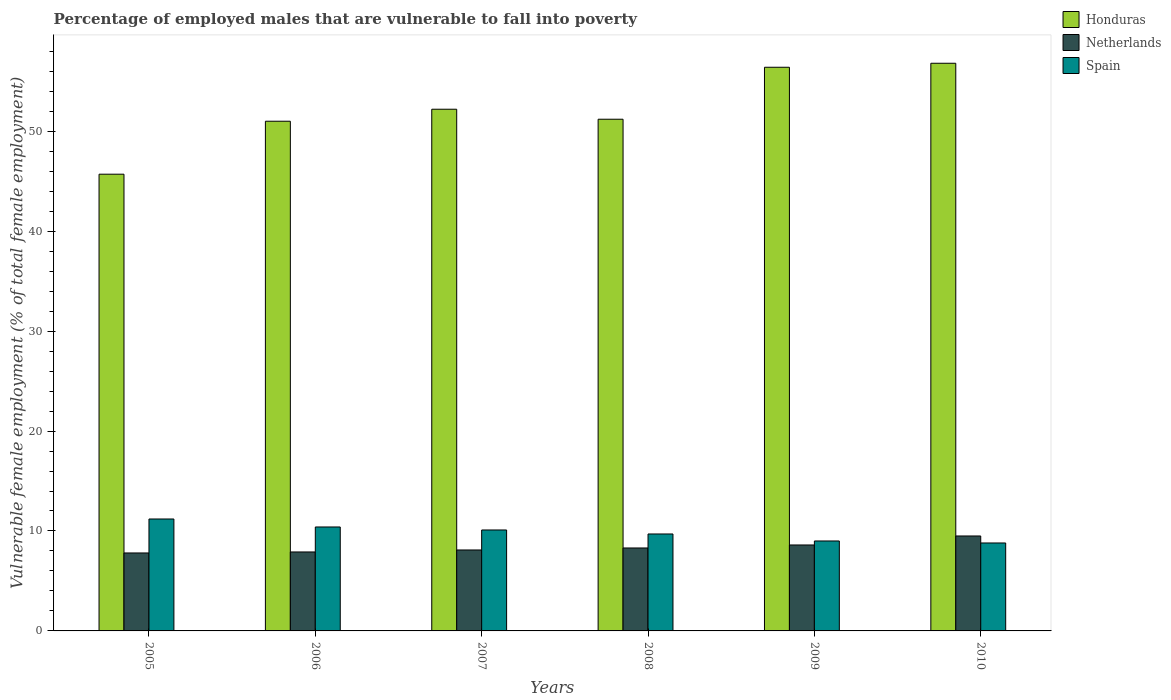Are the number of bars on each tick of the X-axis equal?
Provide a succinct answer. Yes. How many bars are there on the 1st tick from the right?
Offer a very short reply. 3. What is the label of the 4th group of bars from the left?
Your answer should be very brief. 2008. What is the percentage of employed males who are vulnerable to fall into poverty in Spain in 2006?
Make the answer very short. 10.4. Across all years, what is the minimum percentage of employed males who are vulnerable to fall into poverty in Honduras?
Your response must be concise. 45.7. In which year was the percentage of employed males who are vulnerable to fall into poverty in Spain maximum?
Ensure brevity in your answer.  2005. In which year was the percentage of employed males who are vulnerable to fall into poverty in Spain minimum?
Keep it short and to the point. 2010. What is the total percentage of employed males who are vulnerable to fall into poverty in Netherlands in the graph?
Provide a succinct answer. 50.2. What is the difference between the percentage of employed males who are vulnerable to fall into poverty in Honduras in 2005 and that in 2008?
Offer a very short reply. -5.5. What is the difference between the percentage of employed males who are vulnerable to fall into poverty in Honduras in 2007 and the percentage of employed males who are vulnerable to fall into poverty in Spain in 2009?
Your answer should be compact. 43.2. What is the average percentage of employed males who are vulnerable to fall into poverty in Honduras per year?
Keep it short and to the point. 52.22. In the year 2006, what is the difference between the percentage of employed males who are vulnerable to fall into poverty in Spain and percentage of employed males who are vulnerable to fall into poverty in Netherlands?
Provide a short and direct response. 2.5. In how many years, is the percentage of employed males who are vulnerable to fall into poverty in Honduras greater than 44 %?
Your answer should be very brief. 6. What is the ratio of the percentage of employed males who are vulnerable to fall into poverty in Honduras in 2005 to that in 2008?
Your answer should be very brief. 0.89. Is the difference between the percentage of employed males who are vulnerable to fall into poverty in Spain in 2006 and 2009 greater than the difference between the percentage of employed males who are vulnerable to fall into poverty in Netherlands in 2006 and 2009?
Provide a succinct answer. Yes. What is the difference between the highest and the second highest percentage of employed males who are vulnerable to fall into poverty in Spain?
Provide a succinct answer. 0.8. What is the difference between the highest and the lowest percentage of employed males who are vulnerable to fall into poverty in Spain?
Ensure brevity in your answer.  2.4. In how many years, is the percentage of employed males who are vulnerable to fall into poverty in Netherlands greater than the average percentage of employed males who are vulnerable to fall into poverty in Netherlands taken over all years?
Give a very brief answer. 2. Is the sum of the percentage of employed males who are vulnerable to fall into poverty in Honduras in 2005 and 2010 greater than the maximum percentage of employed males who are vulnerable to fall into poverty in Spain across all years?
Your answer should be very brief. Yes. What does the 1st bar from the left in 2008 represents?
Offer a terse response. Honduras. What does the 1st bar from the right in 2005 represents?
Your answer should be very brief. Spain. How many bars are there?
Offer a terse response. 18. What is the difference between two consecutive major ticks on the Y-axis?
Offer a very short reply. 10. Does the graph contain grids?
Your response must be concise. No. What is the title of the graph?
Your response must be concise. Percentage of employed males that are vulnerable to fall into poverty. What is the label or title of the Y-axis?
Offer a very short reply. Vulnerable female employment (% of total female employment). What is the Vulnerable female employment (% of total female employment) of Honduras in 2005?
Offer a very short reply. 45.7. What is the Vulnerable female employment (% of total female employment) of Netherlands in 2005?
Your response must be concise. 7.8. What is the Vulnerable female employment (% of total female employment) in Spain in 2005?
Provide a succinct answer. 11.2. What is the Vulnerable female employment (% of total female employment) of Netherlands in 2006?
Your answer should be very brief. 7.9. What is the Vulnerable female employment (% of total female employment) of Spain in 2006?
Ensure brevity in your answer.  10.4. What is the Vulnerable female employment (% of total female employment) of Honduras in 2007?
Keep it short and to the point. 52.2. What is the Vulnerable female employment (% of total female employment) in Netherlands in 2007?
Provide a succinct answer. 8.1. What is the Vulnerable female employment (% of total female employment) in Spain in 2007?
Your answer should be very brief. 10.1. What is the Vulnerable female employment (% of total female employment) in Honduras in 2008?
Your answer should be compact. 51.2. What is the Vulnerable female employment (% of total female employment) in Netherlands in 2008?
Your answer should be very brief. 8.3. What is the Vulnerable female employment (% of total female employment) in Spain in 2008?
Offer a terse response. 9.7. What is the Vulnerable female employment (% of total female employment) in Honduras in 2009?
Keep it short and to the point. 56.4. What is the Vulnerable female employment (% of total female employment) of Netherlands in 2009?
Provide a short and direct response. 8.6. What is the Vulnerable female employment (% of total female employment) in Honduras in 2010?
Give a very brief answer. 56.8. What is the Vulnerable female employment (% of total female employment) in Spain in 2010?
Your response must be concise. 8.8. Across all years, what is the maximum Vulnerable female employment (% of total female employment) in Honduras?
Keep it short and to the point. 56.8. Across all years, what is the maximum Vulnerable female employment (% of total female employment) in Netherlands?
Your response must be concise. 9.5. Across all years, what is the maximum Vulnerable female employment (% of total female employment) of Spain?
Make the answer very short. 11.2. Across all years, what is the minimum Vulnerable female employment (% of total female employment) of Honduras?
Keep it short and to the point. 45.7. Across all years, what is the minimum Vulnerable female employment (% of total female employment) in Netherlands?
Offer a very short reply. 7.8. Across all years, what is the minimum Vulnerable female employment (% of total female employment) in Spain?
Provide a short and direct response. 8.8. What is the total Vulnerable female employment (% of total female employment) in Honduras in the graph?
Offer a terse response. 313.3. What is the total Vulnerable female employment (% of total female employment) in Netherlands in the graph?
Your response must be concise. 50.2. What is the total Vulnerable female employment (% of total female employment) of Spain in the graph?
Offer a very short reply. 59.2. What is the difference between the Vulnerable female employment (% of total female employment) of Netherlands in 2005 and that in 2006?
Provide a succinct answer. -0.1. What is the difference between the Vulnerable female employment (% of total female employment) in Honduras in 2005 and that in 2007?
Your answer should be very brief. -6.5. What is the difference between the Vulnerable female employment (% of total female employment) of Netherlands in 2005 and that in 2007?
Keep it short and to the point. -0.3. What is the difference between the Vulnerable female employment (% of total female employment) in Spain in 2005 and that in 2007?
Provide a short and direct response. 1.1. What is the difference between the Vulnerable female employment (% of total female employment) in Honduras in 2005 and that in 2008?
Ensure brevity in your answer.  -5.5. What is the difference between the Vulnerable female employment (% of total female employment) in Spain in 2005 and that in 2008?
Offer a terse response. 1.5. What is the difference between the Vulnerable female employment (% of total female employment) in Honduras in 2005 and that in 2009?
Provide a succinct answer. -10.7. What is the difference between the Vulnerable female employment (% of total female employment) in Netherlands in 2005 and that in 2009?
Offer a terse response. -0.8. What is the difference between the Vulnerable female employment (% of total female employment) of Spain in 2005 and that in 2009?
Provide a succinct answer. 2.2. What is the difference between the Vulnerable female employment (% of total female employment) of Spain in 2005 and that in 2010?
Make the answer very short. 2.4. What is the difference between the Vulnerable female employment (% of total female employment) in Netherlands in 2006 and that in 2007?
Make the answer very short. -0.2. What is the difference between the Vulnerable female employment (% of total female employment) of Spain in 2006 and that in 2007?
Your answer should be compact. 0.3. What is the difference between the Vulnerable female employment (% of total female employment) in Honduras in 2006 and that in 2008?
Ensure brevity in your answer.  -0.2. What is the difference between the Vulnerable female employment (% of total female employment) of Netherlands in 2006 and that in 2008?
Provide a succinct answer. -0.4. What is the difference between the Vulnerable female employment (% of total female employment) of Spain in 2006 and that in 2008?
Give a very brief answer. 0.7. What is the difference between the Vulnerable female employment (% of total female employment) of Honduras in 2006 and that in 2009?
Your answer should be very brief. -5.4. What is the difference between the Vulnerable female employment (% of total female employment) in Netherlands in 2006 and that in 2009?
Ensure brevity in your answer.  -0.7. What is the difference between the Vulnerable female employment (% of total female employment) of Spain in 2006 and that in 2009?
Your answer should be compact. 1.4. What is the difference between the Vulnerable female employment (% of total female employment) in Honduras in 2006 and that in 2010?
Offer a terse response. -5.8. What is the difference between the Vulnerable female employment (% of total female employment) of Netherlands in 2006 and that in 2010?
Offer a very short reply. -1.6. What is the difference between the Vulnerable female employment (% of total female employment) in Honduras in 2007 and that in 2008?
Provide a short and direct response. 1. What is the difference between the Vulnerable female employment (% of total female employment) in Netherlands in 2007 and that in 2008?
Your answer should be very brief. -0.2. What is the difference between the Vulnerable female employment (% of total female employment) of Spain in 2007 and that in 2008?
Your response must be concise. 0.4. What is the difference between the Vulnerable female employment (% of total female employment) in Honduras in 2007 and that in 2009?
Provide a short and direct response. -4.2. What is the difference between the Vulnerable female employment (% of total female employment) of Netherlands in 2007 and that in 2009?
Provide a short and direct response. -0.5. What is the difference between the Vulnerable female employment (% of total female employment) in Honduras in 2007 and that in 2010?
Provide a succinct answer. -4.6. What is the difference between the Vulnerable female employment (% of total female employment) in Honduras in 2008 and that in 2009?
Ensure brevity in your answer.  -5.2. What is the difference between the Vulnerable female employment (% of total female employment) in Netherlands in 2008 and that in 2009?
Provide a short and direct response. -0.3. What is the difference between the Vulnerable female employment (% of total female employment) in Netherlands in 2008 and that in 2010?
Your answer should be compact. -1.2. What is the difference between the Vulnerable female employment (% of total female employment) in Netherlands in 2009 and that in 2010?
Your answer should be compact. -0.9. What is the difference between the Vulnerable female employment (% of total female employment) in Honduras in 2005 and the Vulnerable female employment (% of total female employment) in Netherlands in 2006?
Provide a short and direct response. 37.8. What is the difference between the Vulnerable female employment (% of total female employment) of Honduras in 2005 and the Vulnerable female employment (% of total female employment) of Spain in 2006?
Offer a very short reply. 35.3. What is the difference between the Vulnerable female employment (% of total female employment) of Netherlands in 2005 and the Vulnerable female employment (% of total female employment) of Spain in 2006?
Your answer should be compact. -2.6. What is the difference between the Vulnerable female employment (% of total female employment) in Honduras in 2005 and the Vulnerable female employment (% of total female employment) in Netherlands in 2007?
Keep it short and to the point. 37.6. What is the difference between the Vulnerable female employment (% of total female employment) of Honduras in 2005 and the Vulnerable female employment (% of total female employment) of Spain in 2007?
Keep it short and to the point. 35.6. What is the difference between the Vulnerable female employment (% of total female employment) in Netherlands in 2005 and the Vulnerable female employment (% of total female employment) in Spain in 2007?
Offer a very short reply. -2.3. What is the difference between the Vulnerable female employment (% of total female employment) in Honduras in 2005 and the Vulnerable female employment (% of total female employment) in Netherlands in 2008?
Make the answer very short. 37.4. What is the difference between the Vulnerable female employment (% of total female employment) in Honduras in 2005 and the Vulnerable female employment (% of total female employment) in Spain in 2008?
Your answer should be very brief. 36. What is the difference between the Vulnerable female employment (% of total female employment) in Netherlands in 2005 and the Vulnerable female employment (% of total female employment) in Spain in 2008?
Offer a very short reply. -1.9. What is the difference between the Vulnerable female employment (% of total female employment) in Honduras in 2005 and the Vulnerable female employment (% of total female employment) in Netherlands in 2009?
Your answer should be very brief. 37.1. What is the difference between the Vulnerable female employment (% of total female employment) in Honduras in 2005 and the Vulnerable female employment (% of total female employment) in Spain in 2009?
Your response must be concise. 36.7. What is the difference between the Vulnerable female employment (% of total female employment) in Honduras in 2005 and the Vulnerable female employment (% of total female employment) in Netherlands in 2010?
Ensure brevity in your answer.  36.2. What is the difference between the Vulnerable female employment (% of total female employment) of Honduras in 2005 and the Vulnerable female employment (% of total female employment) of Spain in 2010?
Your answer should be very brief. 36.9. What is the difference between the Vulnerable female employment (% of total female employment) in Netherlands in 2005 and the Vulnerable female employment (% of total female employment) in Spain in 2010?
Your answer should be very brief. -1. What is the difference between the Vulnerable female employment (% of total female employment) of Honduras in 2006 and the Vulnerable female employment (% of total female employment) of Netherlands in 2007?
Your response must be concise. 42.9. What is the difference between the Vulnerable female employment (% of total female employment) in Honduras in 2006 and the Vulnerable female employment (% of total female employment) in Spain in 2007?
Make the answer very short. 40.9. What is the difference between the Vulnerable female employment (% of total female employment) of Honduras in 2006 and the Vulnerable female employment (% of total female employment) of Netherlands in 2008?
Provide a short and direct response. 42.7. What is the difference between the Vulnerable female employment (% of total female employment) of Honduras in 2006 and the Vulnerable female employment (% of total female employment) of Spain in 2008?
Your answer should be very brief. 41.3. What is the difference between the Vulnerable female employment (% of total female employment) of Netherlands in 2006 and the Vulnerable female employment (% of total female employment) of Spain in 2008?
Keep it short and to the point. -1.8. What is the difference between the Vulnerable female employment (% of total female employment) in Honduras in 2006 and the Vulnerable female employment (% of total female employment) in Netherlands in 2009?
Your response must be concise. 42.4. What is the difference between the Vulnerable female employment (% of total female employment) of Honduras in 2006 and the Vulnerable female employment (% of total female employment) of Netherlands in 2010?
Keep it short and to the point. 41.5. What is the difference between the Vulnerable female employment (% of total female employment) in Honduras in 2006 and the Vulnerable female employment (% of total female employment) in Spain in 2010?
Provide a short and direct response. 42.2. What is the difference between the Vulnerable female employment (% of total female employment) in Netherlands in 2006 and the Vulnerable female employment (% of total female employment) in Spain in 2010?
Make the answer very short. -0.9. What is the difference between the Vulnerable female employment (% of total female employment) of Honduras in 2007 and the Vulnerable female employment (% of total female employment) of Netherlands in 2008?
Your answer should be very brief. 43.9. What is the difference between the Vulnerable female employment (% of total female employment) of Honduras in 2007 and the Vulnerable female employment (% of total female employment) of Spain in 2008?
Ensure brevity in your answer.  42.5. What is the difference between the Vulnerable female employment (% of total female employment) in Netherlands in 2007 and the Vulnerable female employment (% of total female employment) in Spain in 2008?
Offer a terse response. -1.6. What is the difference between the Vulnerable female employment (% of total female employment) in Honduras in 2007 and the Vulnerable female employment (% of total female employment) in Netherlands in 2009?
Keep it short and to the point. 43.6. What is the difference between the Vulnerable female employment (% of total female employment) in Honduras in 2007 and the Vulnerable female employment (% of total female employment) in Spain in 2009?
Your answer should be compact. 43.2. What is the difference between the Vulnerable female employment (% of total female employment) in Netherlands in 2007 and the Vulnerable female employment (% of total female employment) in Spain in 2009?
Provide a succinct answer. -0.9. What is the difference between the Vulnerable female employment (% of total female employment) in Honduras in 2007 and the Vulnerable female employment (% of total female employment) in Netherlands in 2010?
Make the answer very short. 42.7. What is the difference between the Vulnerable female employment (% of total female employment) of Honduras in 2007 and the Vulnerable female employment (% of total female employment) of Spain in 2010?
Your response must be concise. 43.4. What is the difference between the Vulnerable female employment (% of total female employment) in Netherlands in 2007 and the Vulnerable female employment (% of total female employment) in Spain in 2010?
Your answer should be compact. -0.7. What is the difference between the Vulnerable female employment (% of total female employment) in Honduras in 2008 and the Vulnerable female employment (% of total female employment) in Netherlands in 2009?
Make the answer very short. 42.6. What is the difference between the Vulnerable female employment (% of total female employment) in Honduras in 2008 and the Vulnerable female employment (% of total female employment) in Spain in 2009?
Your answer should be compact. 42.2. What is the difference between the Vulnerable female employment (% of total female employment) in Honduras in 2008 and the Vulnerable female employment (% of total female employment) in Netherlands in 2010?
Your answer should be very brief. 41.7. What is the difference between the Vulnerable female employment (% of total female employment) in Honduras in 2008 and the Vulnerable female employment (% of total female employment) in Spain in 2010?
Your answer should be very brief. 42.4. What is the difference between the Vulnerable female employment (% of total female employment) of Netherlands in 2008 and the Vulnerable female employment (% of total female employment) of Spain in 2010?
Provide a succinct answer. -0.5. What is the difference between the Vulnerable female employment (% of total female employment) in Honduras in 2009 and the Vulnerable female employment (% of total female employment) in Netherlands in 2010?
Provide a succinct answer. 46.9. What is the difference between the Vulnerable female employment (% of total female employment) in Honduras in 2009 and the Vulnerable female employment (% of total female employment) in Spain in 2010?
Ensure brevity in your answer.  47.6. What is the difference between the Vulnerable female employment (% of total female employment) in Netherlands in 2009 and the Vulnerable female employment (% of total female employment) in Spain in 2010?
Offer a terse response. -0.2. What is the average Vulnerable female employment (% of total female employment) in Honduras per year?
Provide a succinct answer. 52.22. What is the average Vulnerable female employment (% of total female employment) of Netherlands per year?
Your answer should be very brief. 8.37. What is the average Vulnerable female employment (% of total female employment) in Spain per year?
Offer a very short reply. 9.87. In the year 2005, what is the difference between the Vulnerable female employment (% of total female employment) in Honduras and Vulnerable female employment (% of total female employment) in Netherlands?
Give a very brief answer. 37.9. In the year 2005, what is the difference between the Vulnerable female employment (% of total female employment) of Honduras and Vulnerable female employment (% of total female employment) of Spain?
Your answer should be very brief. 34.5. In the year 2005, what is the difference between the Vulnerable female employment (% of total female employment) of Netherlands and Vulnerable female employment (% of total female employment) of Spain?
Offer a very short reply. -3.4. In the year 2006, what is the difference between the Vulnerable female employment (% of total female employment) in Honduras and Vulnerable female employment (% of total female employment) in Netherlands?
Ensure brevity in your answer.  43.1. In the year 2006, what is the difference between the Vulnerable female employment (% of total female employment) in Honduras and Vulnerable female employment (% of total female employment) in Spain?
Your answer should be very brief. 40.6. In the year 2007, what is the difference between the Vulnerable female employment (% of total female employment) of Honduras and Vulnerable female employment (% of total female employment) of Netherlands?
Provide a succinct answer. 44.1. In the year 2007, what is the difference between the Vulnerable female employment (% of total female employment) in Honduras and Vulnerable female employment (% of total female employment) in Spain?
Offer a very short reply. 42.1. In the year 2008, what is the difference between the Vulnerable female employment (% of total female employment) in Honduras and Vulnerable female employment (% of total female employment) in Netherlands?
Offer a very short reply. 42.9. In the year 2008, what is the difference between the Vulnerable female employment (% of total female employment) of Honduras and Vulnerable female employment (% of total female employment) of Spain?
Provide a succinct answer. 41.5. In the year 2008, what is the difference between the Vulnerable female employment (% of total female employment) of Netherlands and Vulnerable female employment (% of total female employment) of Spain?
Your answer should be very brief. -1.4. In the year 2009, what is the difference between the Vulnerable female employment (% of total female employment) of Honduras and Vulnerable female employment (% of total female employment) of Netherlands?
Provide a succinct answer. 47.8. In the year 2009, what is the difference between the Vulnerable female employment (% of total female employment) of Honduras and Vulnerable female employment (% of total female employment) of Spain?
Make the answer very short. 47.4. In the year 2010, what is the difference between the Vulnerable female employment (% of total female employment) of Honduras and Vulnerable female employment (% of total female employment) of Netherlands?
Your answer should be very brief. 47.3. In the year 2010, what is the difference between the Vulnerable female employment (% of total female employment) in Honduras and Vulnerable female employment (% of total female employment) in Spain?
Your response must be concise. 48. In the year 2010, what is the difference between the Vulnerable female employment (% of total female employment) in Netherlands and Vulnerable female employment (% of total female employment) in Spain?
Your answer should be compact. 0.7. What is the ratio of the Vulnerable female employment (% of total female employment) in Honduras in 2005 to that in 2006?
Your answer should be very brief. 0.9. What is the ratio of the Vulnerable female employment (% of total female employment) of Netherlands in 2005 to that in 2006?
Offer a terse response. 0.99. What is the ratio of the Vulnerable female employment (% of total female employment) in Honduras in 2005 to that in 2007?
Offer a very short reply. 0.88. What is the ratio of the Vulnerable female employment (% of total female employment) of Spain in 2005 to that in 2007?
Ensure brevity in your answer.  1.11. What is the ratio of the Vulnerable female employment (% of total female employment) of Honduras in 2005 to that in 2008?
Make the answer very short. 0.89. What is the ratio of the Vulnerable female employment (% of total female employment) of Netherlands in 2005 to that in 2008?
Provide a short and direct response. 0.94. What is the ratio of the Vulnerable female employment (% of total female employment) of Spain in 2005 to that in 2008?
Give a very brief answer. 1.15. What is the ratio of the Vulnerable female employment (% of total female employment) of Honduras in 2005 to that in 2009?
Offer a terse response. 0.81. What is the ratio of the Vulnerable female employment (% of total female employment) in Netherlands in 2005 to that in 2009?
Give a very brief answer. 0.91. What is the ratio of the Vulnerable female employment (% of total female employment) in Spain in 2005 to that in 2009?
Give a very brief answer. 1.24. What is the ratio of the Vulnerable female employment (% of total female employment) in Honduras in 2005 to that in 2010?
Make the answer very short. 0.8. What is the ratio of the Vulnerable female employment (% of total female employment) of Netherlands in 2005 to that in 2010?
Ensure brevity in your answer.  0.82. What is the ratio of the Vulnerable female employment (% of total female employment) in Spain in 2005 to that in 2010?
Keep it short and to the point. 1.27. What is the ratio of the Vulnerable female employment (% of total female employment) of Netherlands in 2006 to that in 2007?
Your response must be concise. 0.98. What is the ratio of the Vulnerable female employment (% of total female employment) of Spain in 2006 to that in 2007?
Your answer should be compact. 1.03. What is the ratio of the Vulnerable female employment (% of total female employment) in Honduras in 2006 to that in 2008?
Offer a very short reply. 1. What is the ratio of the Vulnerable female employment (% of total female employment) of Netherlands in 2006 to that in 2008?
Provide a short and direct response. 0.95. What is the ratio of the Vulnerable female employment (% of total female employment) of Spain in 2006 to that in 2008?
Provide a short and direct response. 1.07. What is the ratio of the Vulnerable female employment (% of total female employment) in Honduras in 2006 to that in 2009?
Make the answer very short. 0.9. What is the ratio of the Vulnerable female employment (% of total female employment) in Netherlands in 2006 to that in 2009?
Give a very brief answer. 0.92. What is the ratio of the Vulnerable female employment (% of total female employment) in Spain in 2006 to that in 2009?
Keep it short and to the point. 1.16. What is the ratio of the Vulnerable female employment (% of total female employment) in Honduras in 2006 to that in 2010?
Provide a succinct answer. 0.9. What is the ratio of the Vulnerable female employment (% of total female employment) of Netherlands in 2006 to that in 2010?
Your response must be concise. 0.83. What is the ratio of the Vulnerable female employment (% of total female employment) in Spain in 2006 to that in 2010?
Give a very brief answer. 1.18. What is the ratio of the Vulnerable female employment (% of total female employment) of Honduras in 2007 to that in 2008?
Your answer should be very brief. 1.02. What is the ratio of the Vulnerable female employment (% of total female employment) in Netherlands in 2007 to that in 2008?
Your response must be concise. 0.98. What is the ratio of the Vulnerable female employment (% of total female employment) of Spain in 2007 to that in 2008?
Offer a very short reply. 1.04. What is the ratio of the Vulnerable female employment (% of total female employment) in Honduras in 2007 to that in 2009?
Provide a succinct answer. 0.93. What is the ratio of the Vulnerable female employment (% of total female employment) in Netherlands in 2007 to that in 2009?
Your response must be concise. 0.94. What is the ratio of the Vulnerable female employment (% of total female employment) in Spain in 2007 to that in 2009?
Ensure brevity in your answer.  1.12. What is the ratio of the Vulnerable female employment (% of total female employment) in Honduras in 2007 to that in 2010?
Provide a succinct answer. 0.92. What is the ratio of the Vulnerable female employment (% of total female employment) in Netherlands in 2007 to that in 2010?
Your answer should be very brief. 0.85. What is the ratio of the Vulnerable female employment (% of total female employment) in Spain in 2007 to that in 2010?
Your response must be concise. 1.15. What is the ratio of the Vulnerable female employment (% of total female employment) of Honduras in 2008 to that in 2009?
Offer a terse response. 0.91. What is the ratio of the Vulnerable female employment (% of total female employment) in Netherlands in 2008 to that in 2009?
Give a very brief answer. 0.97. What is the ratio of the Vulnerable female employment (% of total female employment) in Spain in 2008 to that in 2009?
Give a very brief answer. 1.08. What is the ratio of the Vulnerable female employment (% of total female employment) in Honduras in 2008 to that in 2010?
Your answer should be compact. 0.9. What is the ratio of the Vulnerable female employment (% of total female employment) of Netherlands in 2008 to that in 2010?
Ensure brevity in your answer.  0.87. What is the ratio of the Vulnerable female employment (% of total female employment) in Spain in 2008 to that in 2010?
Keep it short and to the point. 1.1. What is the ratio of the Vulnerable female employment (% of total female employment) in Netherlands in 2009 to that in 2010?
Offer a very short reply. 0.91. What is the ratio of the Vulnerable female employment (% of total female employment) of Spain in 2009 to that in 2010?
Keep it short and to the point. 1.02. What is the difference between the highest and the second highest Vulnerable female employment (% of total female employment) in Netherlands?
Provide a succinct answer. 0.9. What is the difference between the highest and the lowest Vulnerable female employment (% of total female employment) in Netherlands?
Offer a very short reply. 1.7. What is the difference between the highest and the lowest Vulnerable female employment (% of total female employment) in Spain?
Your answer should be very brief. 2.4. 